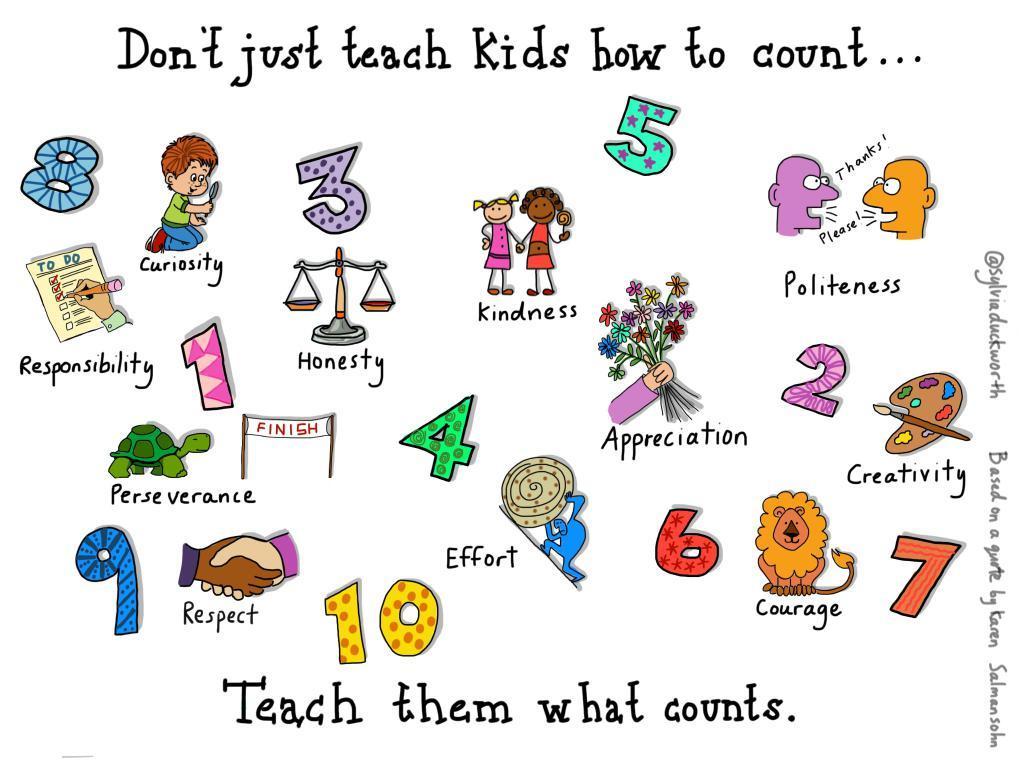Could you give a brief overview of what you see in this image? In this picture we can see cartoon pictures and numbers. 